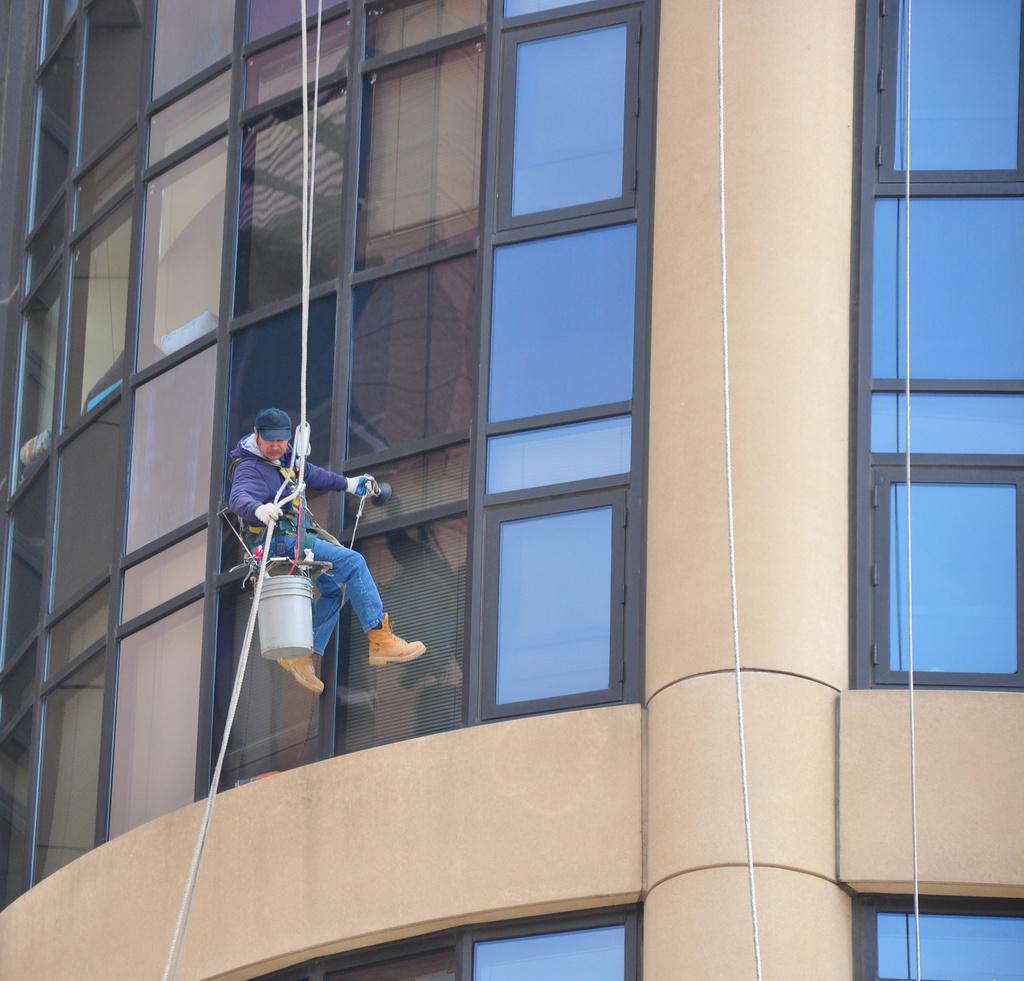How would you summarize this image in a sentence or two? In this image there is a building and we can see a person cleaning the glass and there are ropes. 